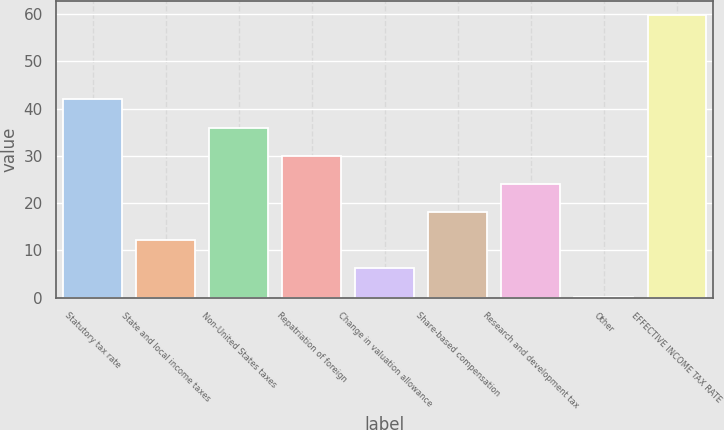<chart> <loc_0><loc_0><loc_500><loc_500><bar_chart><fcel>Statutory tax rate<fcel>State and local income taxes<fcel>Non-United States taxes<fcel>Repatriation of foreign<fcel>Change in valuation allowance<fcel>Share-based compensation<fcel>Research and development tax<fcel>Other<fcel>EFFECTIVE INCOME TAX RATE<nl><fcel>41.92<fcel>12.12<fcel>35.96<fcel>30<fcel>6.16<fcel>18.08<fcel>24.04<fcel>0.2<fcel>59.8<nl></chart> 